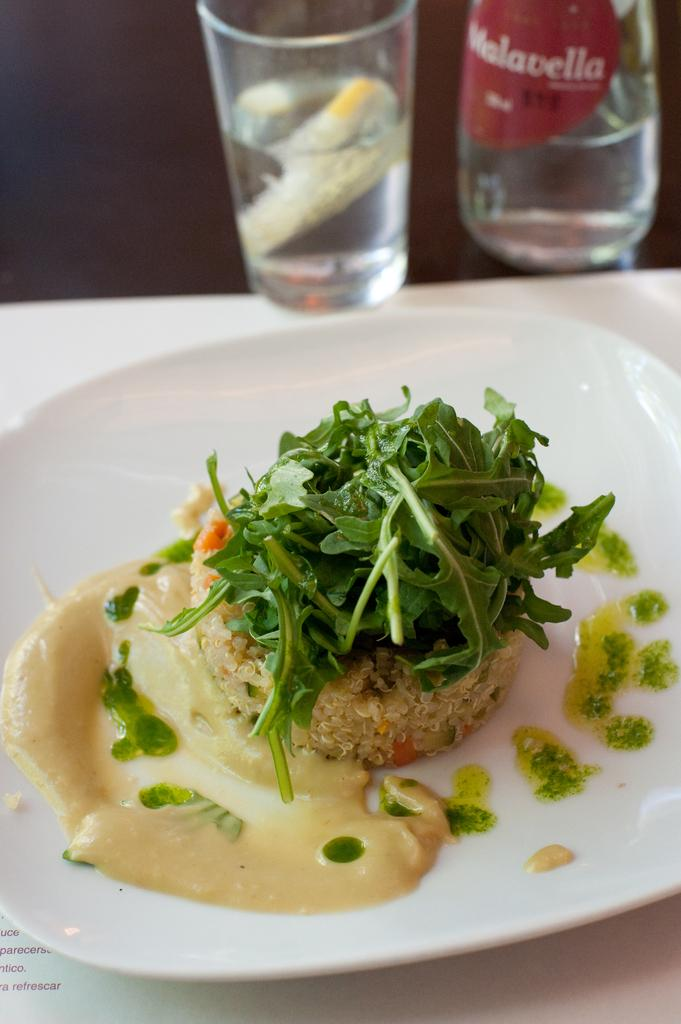<image>
Render a clear and concise summary of the photo. A bottle of Malavella sits behind a plate of fancy food. 